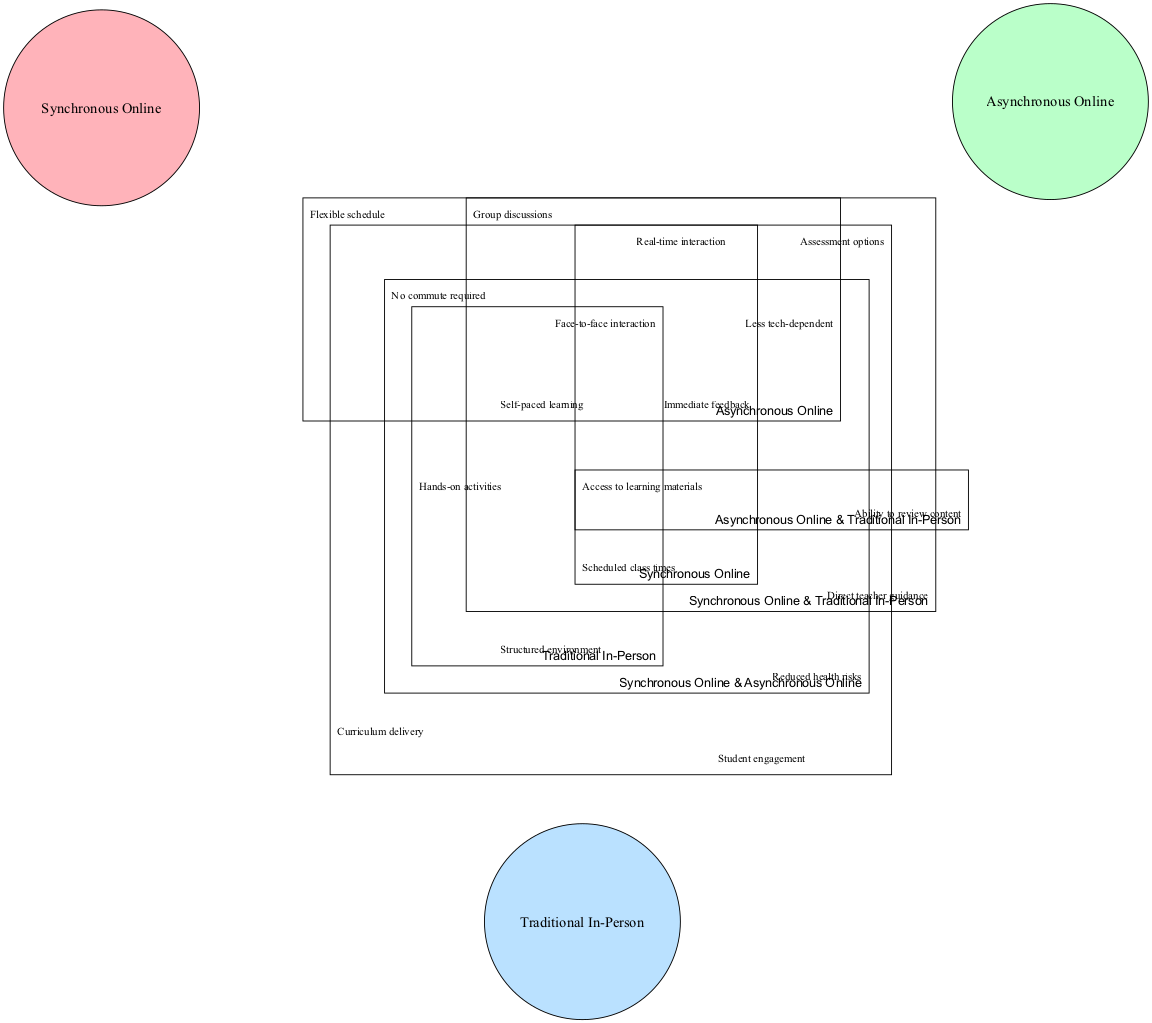What are the elements listed under Synchronous Online? The diagram contains specific elements in each set. For the "Synchronous Online" set, the elements listed are real-time interaction, scheduled class times, and immediate feedback.
Answer: Real-time interaction, scheduled class times, immediate feedback How many elements are shared between Synchronous Online and Asynchronous Online? The shared elements between the "Synchronous Online" and "Asynchronous Online" sets are listed in the intersection section. There are two elements mentioned: reduced health risks and no commute required.
Answer: 2 What is a common benefit of all three instruction types? The diagram indicates that all three instruction types share some common benefits, specifically listed as curriculum delivery, student engagement, and assessment options. Therefore, we consider these benefits collectively.
Answer: Curriculum delivery, student engagement, assessment options Which instruction type includes hands-on activities as an element? Looking at the elements listed under the "Traditional In-Person" set, one of the mentioned elements is hands-on activities. Thus, this instruction type encompasses this element.
Answer: Traditional In-Person What is an exclusive feature of Asynchronous Online classes? The "Asynchronous Online" set has unique elements that set it apart. One exclusive feature is self-paced learning, which is not listed under the other two instruction types.
Answer: Self-paced learning Which elements overlap among all instruction types in the Venn diagram? The overlap among all three instruction types contains shared elements that apply to each type. Specifically, it includes curriculum delivery, student engagement, and assessment options, which are essential aspects present across the board.
Answer: Curriculum delivery, student engagement, assessment options What is a defining characteristic of Synchronous Online classes? In the diagram, a defining characteristic of "Synchronous Online" classes is immediate feedback. This feature highlights the real-time assessment and interaction aspect of these classes.
Answer: Immediate feedback What benefit do Synchronous Online and Traditional In-Person share? The benefit shared between "Synchronous Online" and "Traditional In-Person" is direct teacher guidance, emphasizing the benefit of teacher support in both learning environments.
Answer: Direct teacher guidance 